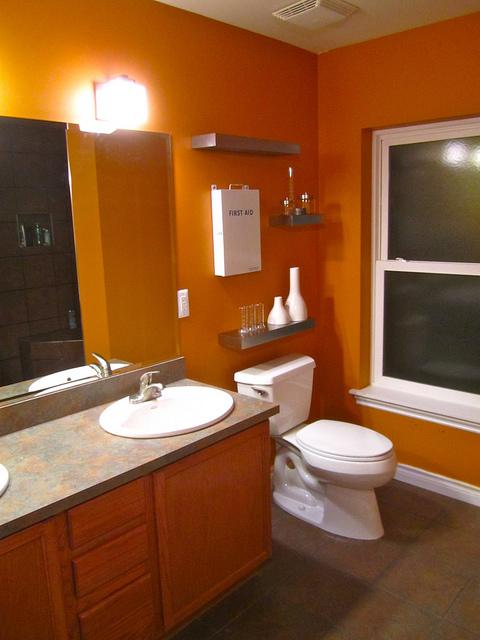Is it daytime?
Be succinct. No. Which relative would be most likely to have this bathroom?
Be succinct. Mother. What kind of room is this?
Write a very short answer. Bathroom. How many cabinets are above the sink?
Be succinct. 0. What room is this?
Concise answer only. Bathroom. Is there a window in the room?
Be succinct. Yes. 